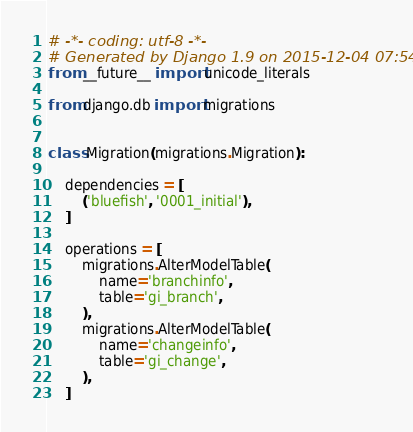Convert code to text. <code><loc_0><loc_0><loc_500><loc_500><_Python_># -*- coding: utf-8 -*-
# Generated by Django 1.9 on 2015-12-04 07:54
from __future__ import unicode_literals

from django.db import migrations


class Migration(migrations.Migration):

    dependencies = [
        ('bluefish', '0001_initial'),
    ]

    operations = [
        migrations.AlterModelTable(
            name='branchinfo',
            table='gi_branch',
        ),
        migrations.AlterModelTable(
            name='changeinfo',
            table='gi_change',
        ),
    ]
</code> 